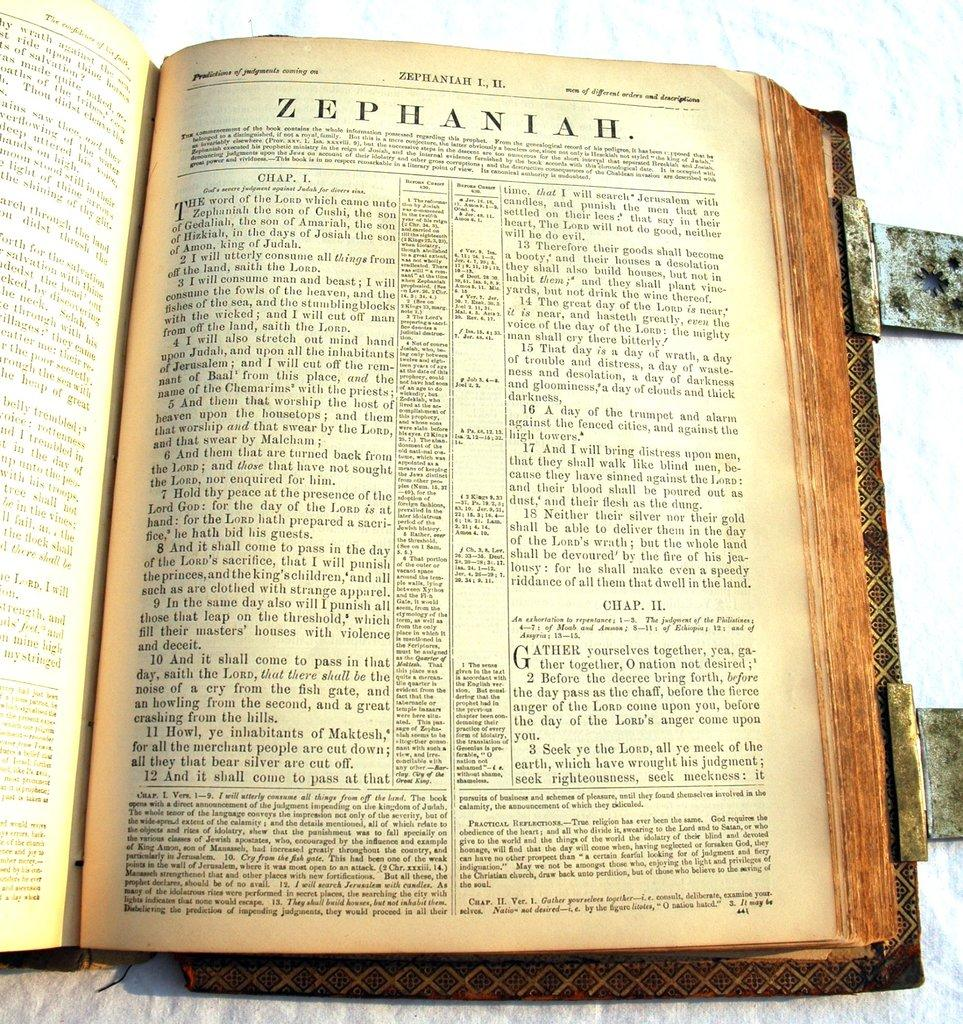<image>
Relay a brief, clear account of the picture shown. Zephaniah chapter 1 verse 13 states that therefore their goods will become a booty. 